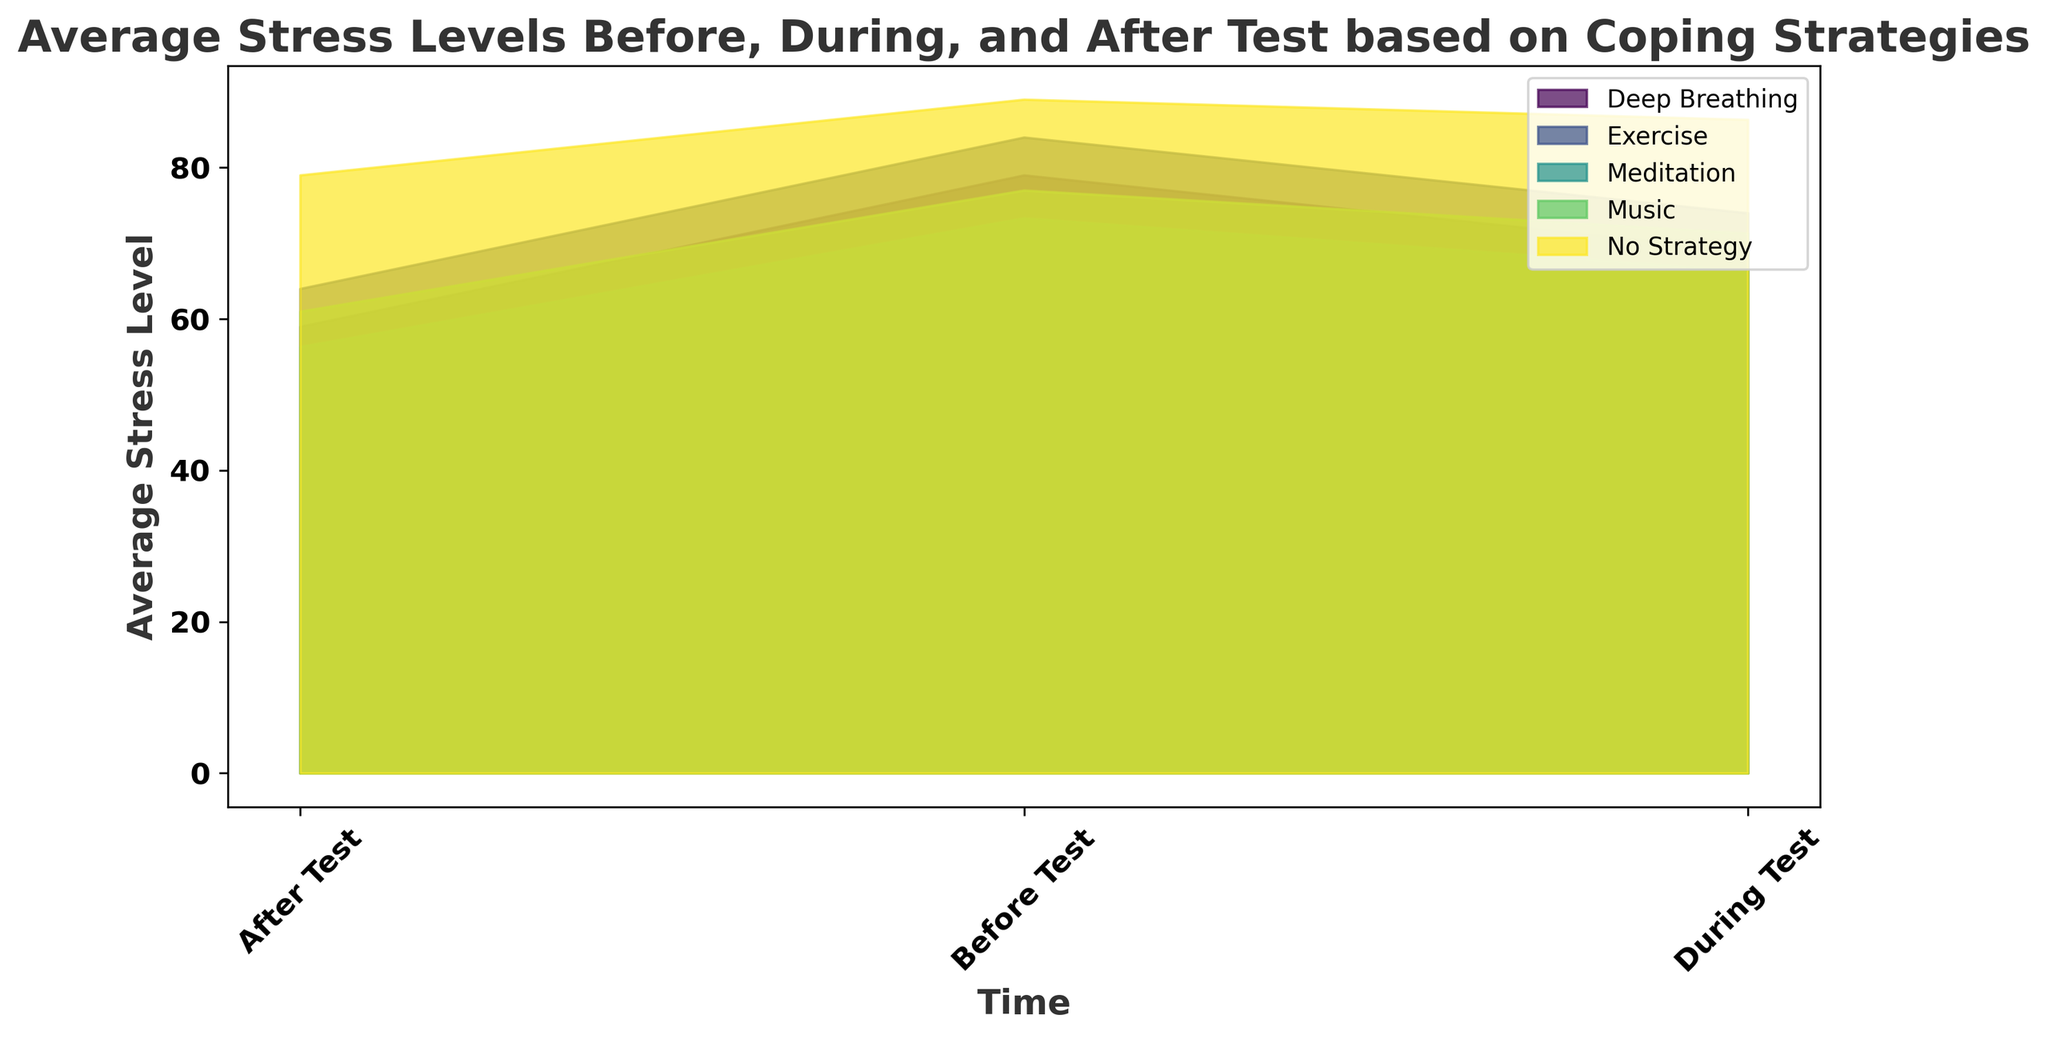What coping strategy shows the lowest average stress level after the test? First, look at the "After Test" values for each coping strategy. Identify the coping strategy with the smallest number.
Answer: Meditation Which coping strategy has the most significant decrease in average stress levels from before to during the test? Compare the average stress levels before the test and during the test for each coping strategy. Calculate the difference and find the maximum value among these differences.
Answer: Meditation What is the average stress level for deep breathing across all time points? Sum the stress levels for deep breathing in "Before Test," "During Test," and "After Test" and divide by the number of time points. Average = (80+78+79 + 70+68+69 + 60+58+59)/9 = (704)/9 ≈ 78.22
Answer: 78.22 By how much does the "No Strategy" stress level decrease from before to after the test? Subtract the "After Test" stress level from the "Before Test" stress level for "No Strategy." Consider all three repeated entries for both. Decrease = 89 - 78 = 11
Answer: 11 Which coping strategy shows a consistent decrease in stress levels across all three time points? Check the trend for each coping strategy from "Before Test" to "During Test" to "After Test." Identify the strategy with a consistent downward trend in stress levels.
Answer: Meditation How does the stress level for exercise compare during and after the test? Look at the stress levels for exercise "During Test" and "After Test" and compare the two values.
Answer: During test levels are higher than after test levels What is the difference between the highest and the lowest stress levels recorded before the test? Identify the highest and lowest values recorded "Before Test" and subtract the lowest from the highest. Difference = 89 - 72 = 17
Answer: 17 Which coping strategy has its highest recorded average stress level during the test? Compare the stress levels for each coping strategy during the test and find the highest value.
Answer: Exercise 